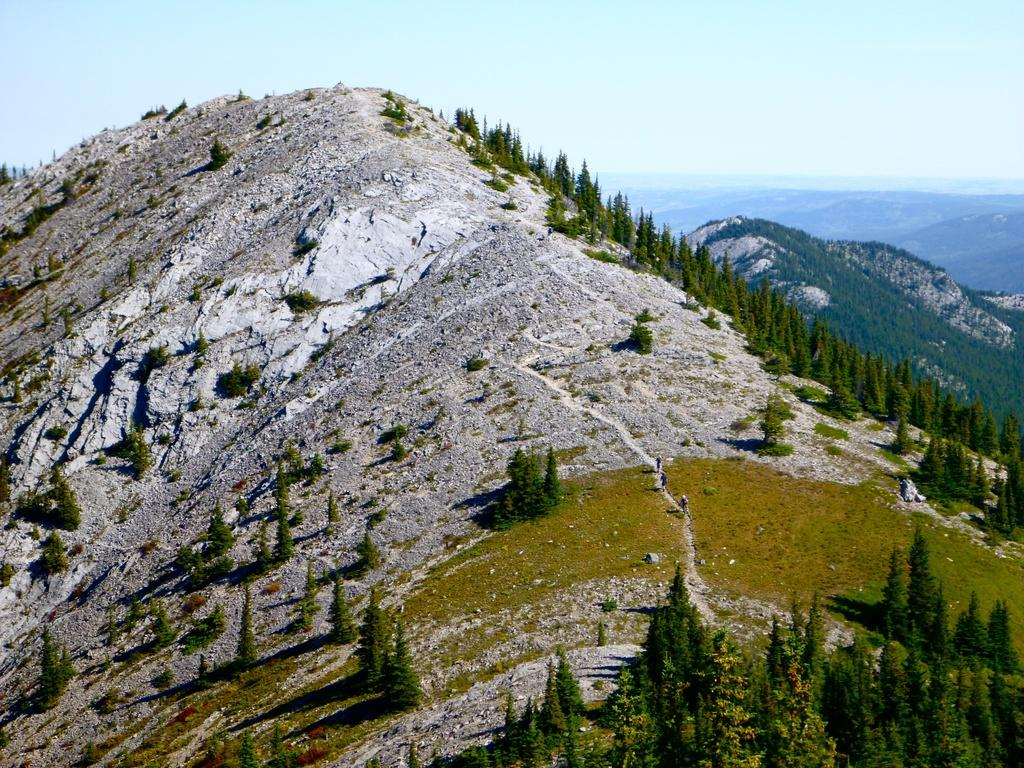What is the main subject of the image? The main subject of the image is a mountain. What are the people in the image doing? There are three people walking on the mountain. What type of vegetation can be seen in the image? There are many trees in the image. What can be seen in the background of the image? There are other mountains visible in the background. What type of camera is being used by the writer in the image? There is no camera or writer present in the image; it only depicts a mountain with people walking on it and trees. 